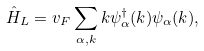Convert formula to latex. <formula><loc_0><loc_0><loc_500><loc_500>\hat { H } _ { L } = v _ { F } \sum _ { \alpha , k } k \psi ^ { \dag } _ { \alpha } ( k ) \psi _ { \alpha } ( k ) ,</formula> 